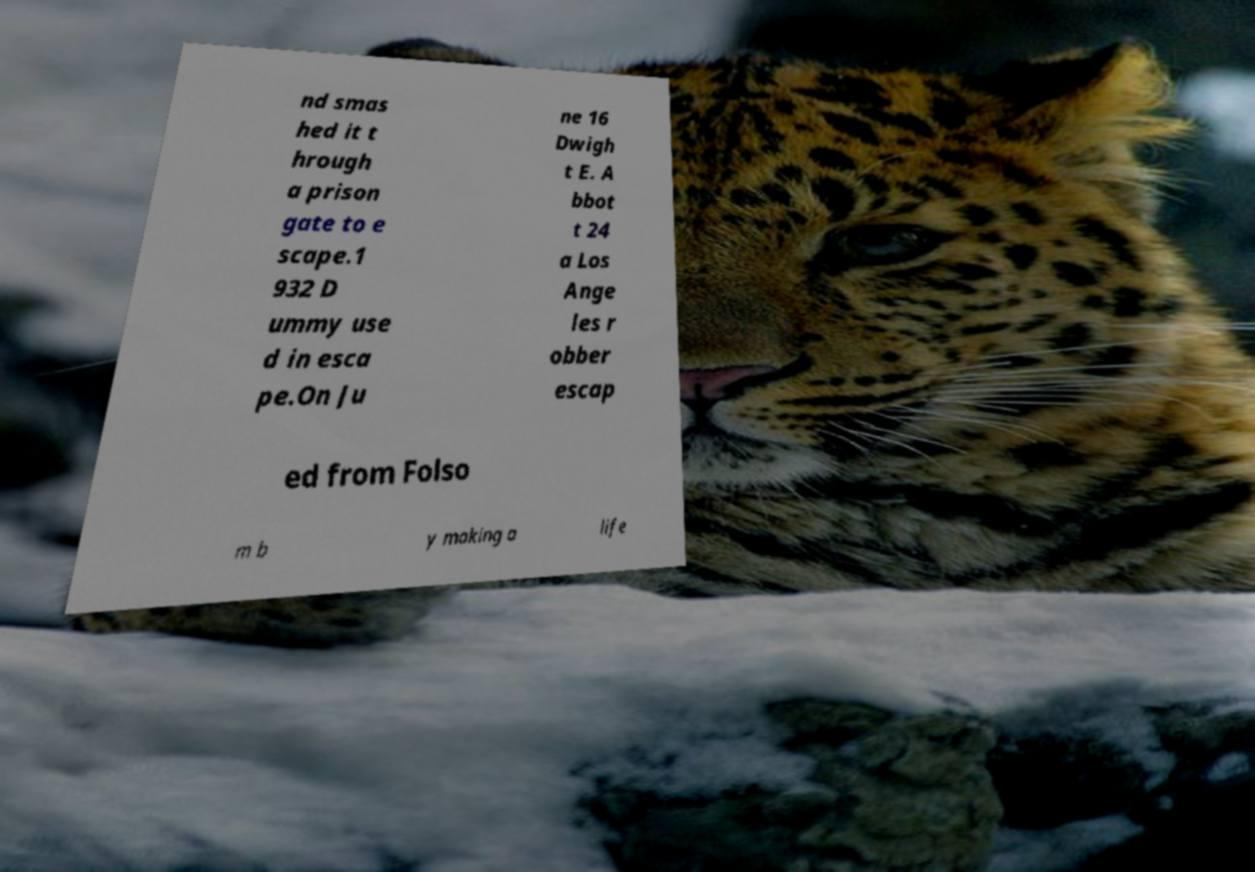For documentation purposes, I need the text within this image transcribed. Could you provide that? nd smas hed it t hrough a prison gate to e scape.1 932 D ummy use d in esca pe.On Ju ne 16 Dwigh t E. A bbot t 24 a Los Ange les r obber escap ed from Folso m b y making a life 